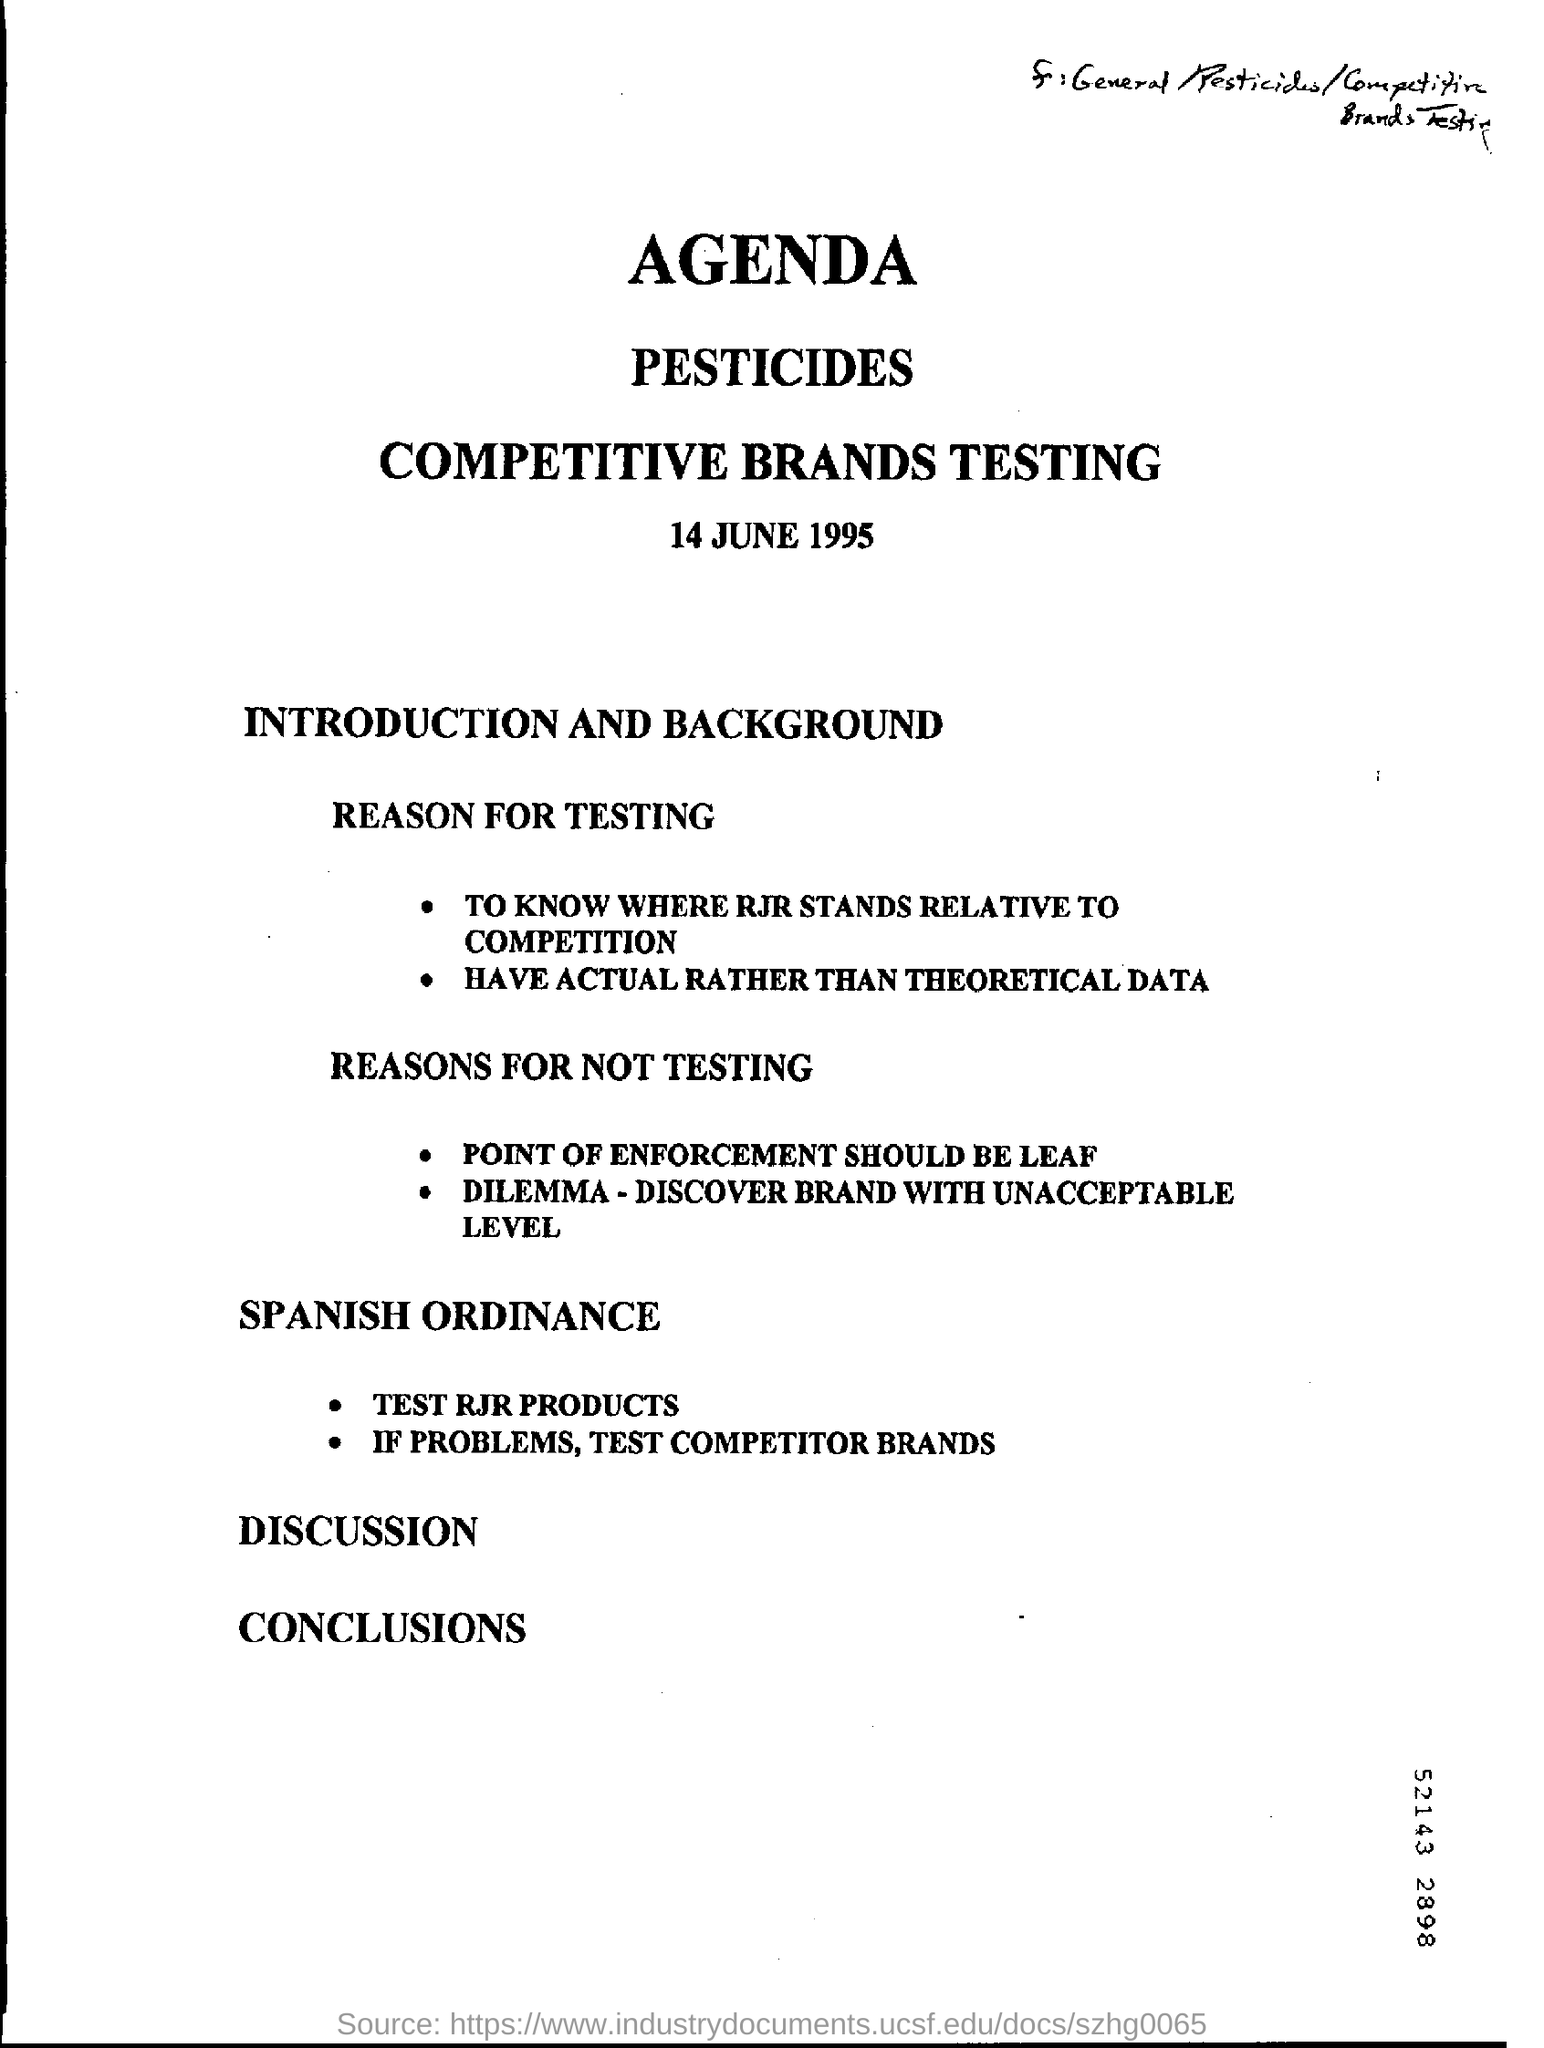What is the date mention in this document?
Make the answer very short. 14 JUNE 1995. 